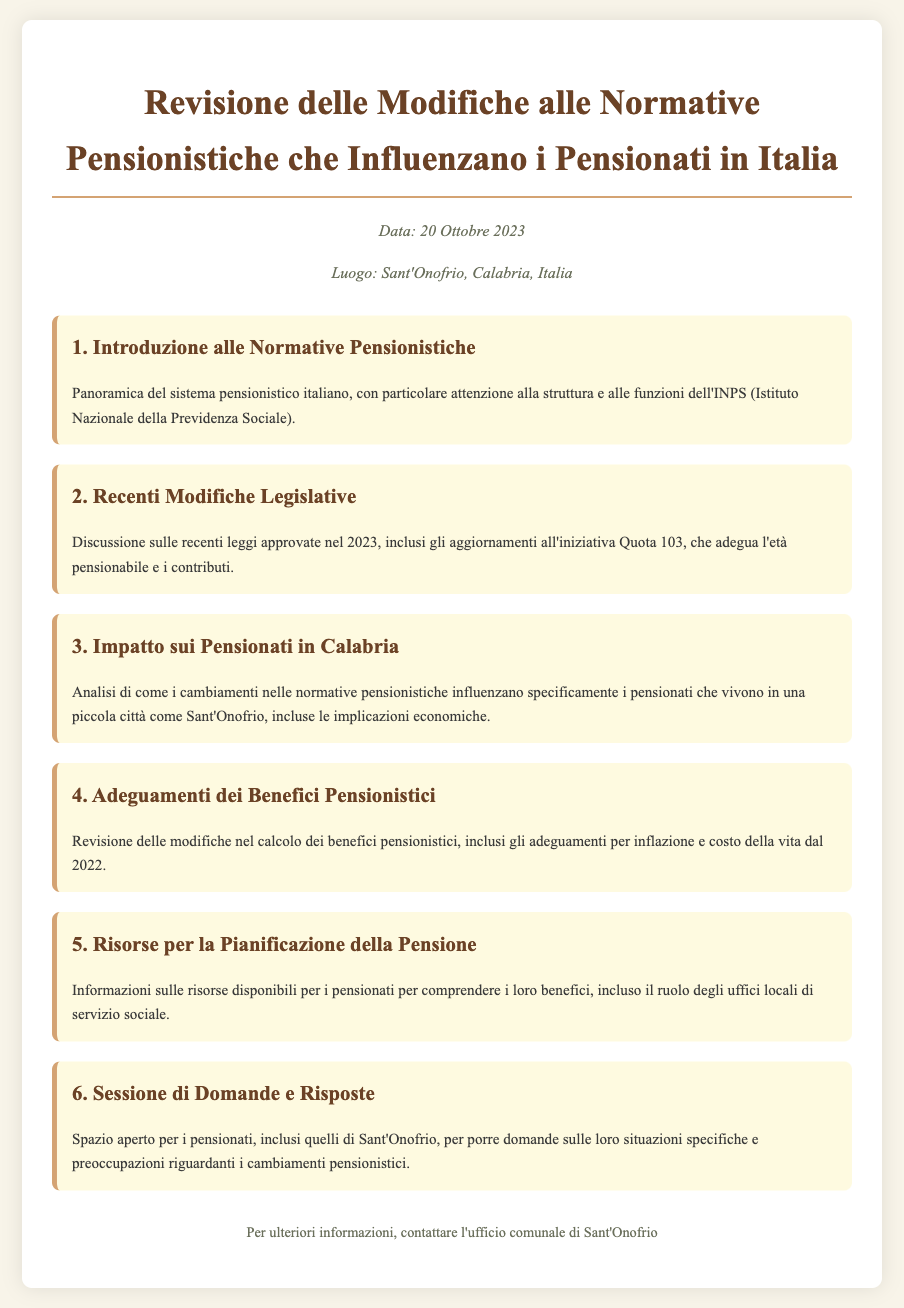What is the date of the document? The date is mentioned in the document as the specific day for the agenda review.
Answer: 20 Ottobre 2023 What is the place of the meeting? The place is provided in the introductory section of the document, indicating where the agenda is taking place.
Answer: Sant'Onofrio, Calabria, Italia What does INPS stand for? The document provides the full form of the abbreviation INPS in the context of pension regulations in Italy.
Answer: Istituto Nazionale della Previdenza Sociale What is Quota 103? The document mentions this legislative initiative as part of the recent changes to pension regulations.
Answer: Un aggiornamento dell'età pensionabile e i contributi Which year were the recent legislative modifications approved? The document specifies the year when certain laws regarding pensions were enacted.
Answer: 2023 What is the focus of the analysis regarding pensioners in Calabria? The document outlines the specific analysis regarding the implications on pensioners living in a specific locale.
Answer: Implicazioni economiche What are the adjustments discussed for pension benefits? The document discusses modifications in pension benefits, particularly their relation to inflation and living costs.
Answer: Adeguamenti per inflazione e costo della vita What kind of resources are mentioned for pension planning? The document indicates particular resources available for retirees to help them understand their benefits.
Answer: Uffici locali di servizio sociale What section allows retirees to ask questions? The document clearly identifies a part dedicated to addressing inquiries from retirees regarding pension changes.
Answer: Sessione di Domande e Risposte 